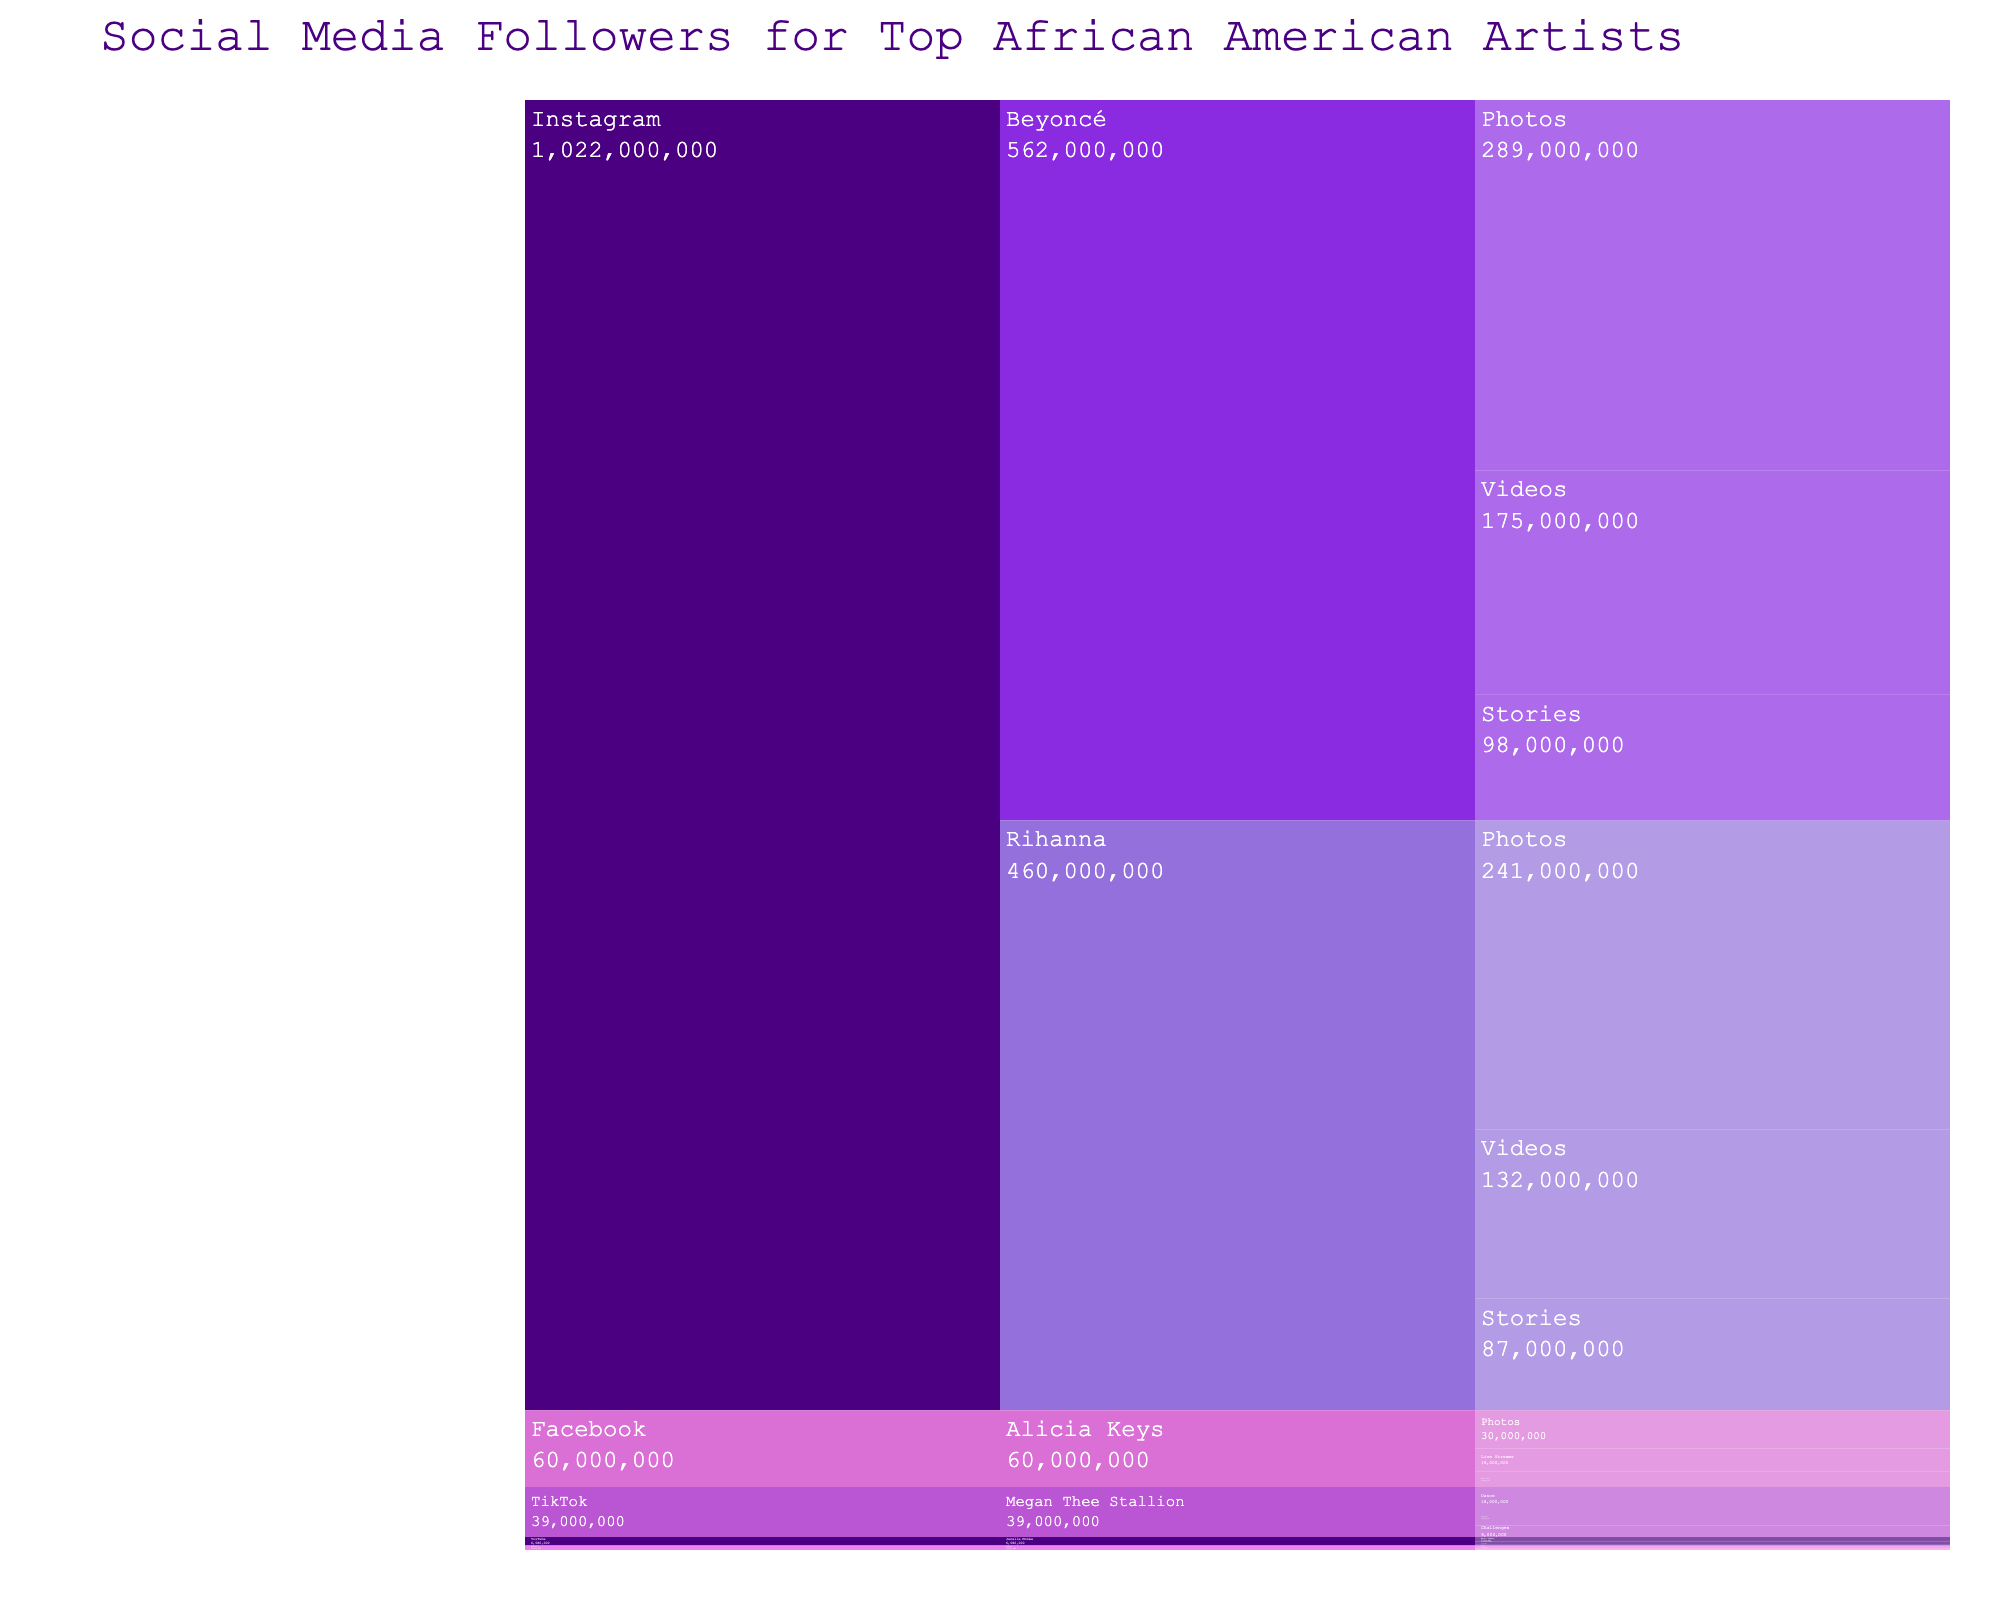What is the title of the icicle chart? The title specifies the main topic of the chart and usually appears at the top. In the rendered figure, the title is clearly displayed at the top.
Answer: Social Media Followers for Top African American Artists Which artist has the most followers on Instagram? To answer this, we need to look under the Instagram section and compare the follower counts for each artist. Beyoncé has 289,000,000 (Photos), 175,000,000 (Videos), and 98,000,000 (Stories), while Rihanna has 241,000,000 (Photos), 132,000,000 (Videos), and 87,000,000 (Stories). Beyoncé has higher numbers in each content type.
Answer: Beyoncé How many total followers does Megan Thee Stallion have on TikTok? We need to sum the followers across all content types for Megan Thee Stallion on TikTok as shown in the figure: 18,000,000 (Dance) + 12,000,000 (Lip Sync) + 9,000,000 (Challenges).
Answer: 39,000,000 Who has more followers on YouTube, Janelle Monáe or Alicia Keys on Facebook? Compare the sum of Janelle Monáe's followers on YouTube with Alicia Keys' followers on Facebook: Janelle (3,500,000 + 2,100,000 + 980,000) vs. Alicia (30,000,000 + 18,000,000 + 12,000,000). Janelle's total is 6,580,000 and Alicia's is 60,000,000.
Answer: Alicia Keys Which content type for Rihanna on Instagram has the least number of followers? Check Rihanna’s section under Instagram and compare her follower counts for Photos, Videos, and Stories. Stories have the least followers among the three.
Answer: Stories What is the difference in the number of followers between Beyoncé's Photos and Rihanna's Photos on Instagram? Compare Beyoncé's Photos followers (289,000,000) to Rihanna's Photos followers (241,000,000) and find the difference: 289,000,000 - 241,000,000.
Answer: 48,000,000 Which platform has the most cumulative followers for the artists represented? To determine this, sum the followers for each artist across all platforms: Instagram, Twitter, TikTok, YouTube, and Facebook. We would see that Instagram and Facebook appear to have the highest numbers, but Instagram has more artists with higher follower counts cumulatively.
Answer: Instagram How many followers does Lizzo have for Retweets on Twitter? Refer to the section for Twitter and check the specific content type for Retweets under Lizzo. The figure clearly lists this number.
Answer: 980,000 Which artist has the least representation across the platforms listed? Check the count of platforms each artist is represented across. Lizzo is represented only on Twitter, while others are on more multiple platforms.
Answer: Lizzo Among the artists listed, who has the highest total number of followers across all platforms? Sum the total followers for each artist across all platforms they are listed on. Beyoncé has the highest cumulative number with sums from Instagram's different content types making the highest total.
Answer: Beyoncé 